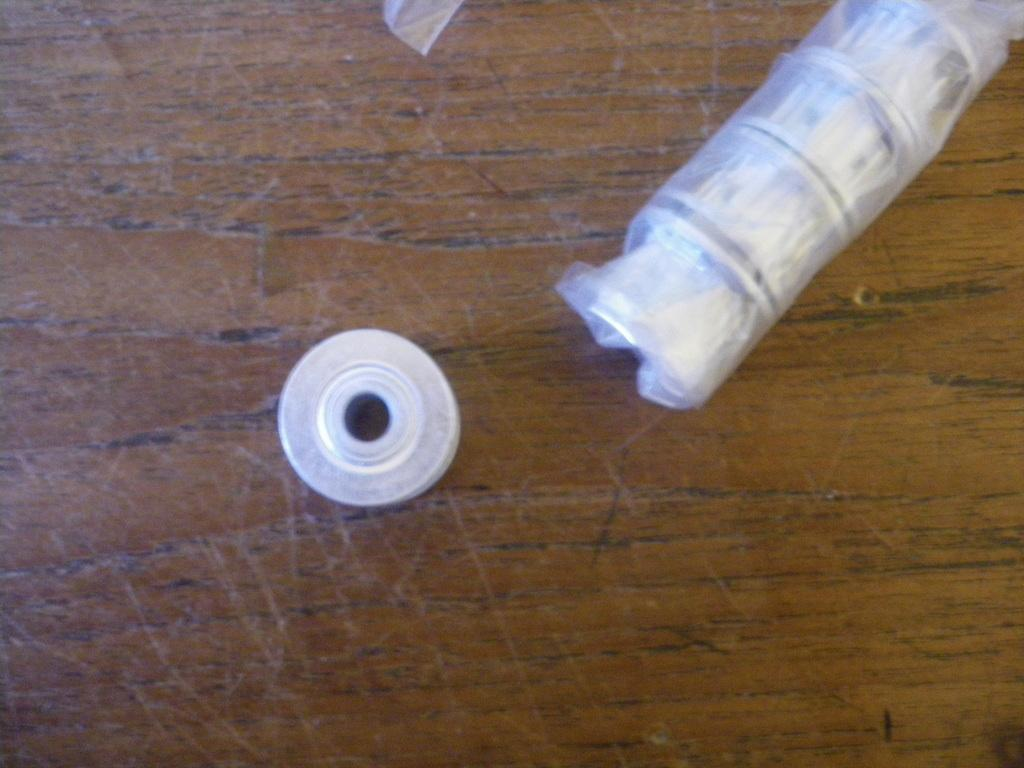What can be seen on the table in the image? There are two objects on a table in the image. Can you tell me how many cherries are on the table in the image? There is no information about cherries in the image, so it cannot be determined if any are present. 